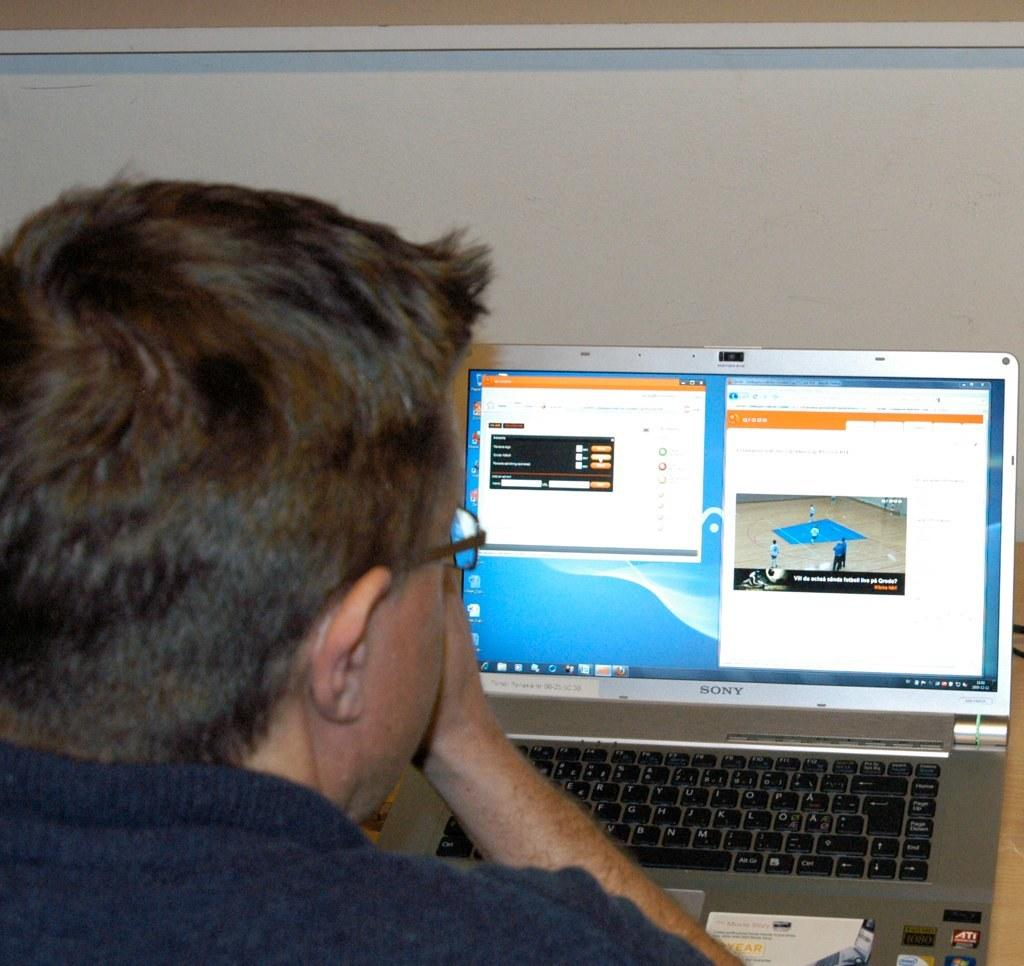<image>
Relay a brief, clear account of the picture shown. A man looks at the screen of a  Sony laptop which has a Firefox browser open. 